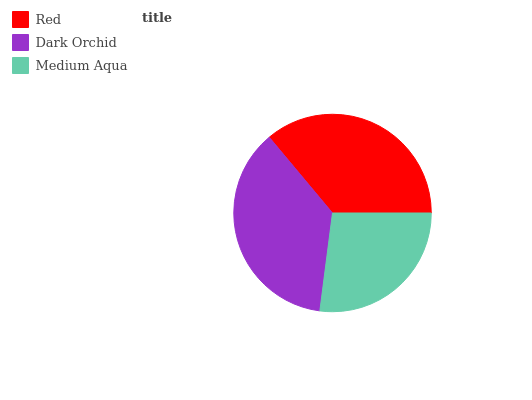Is Medium Aqua the minimum?
Answer yes or no. Yes. Is Dark Orchid the maximum?
Answer yes or no. Yes. Is Dark Orchid the minimum?
Answer yes or no. No. Is Medium Aqua the maximum?
Answer yes or no. No. Is Dark Orchid greater than Medium Aqua?
Answer yes or no. Yes. Is Medium Aqua less than Dark Orchid?
Answer yes or no. Yes. Is Medium Aqua greater than Dark Orchid?
Answer yes or no. No. Is Dark Orchid less than Medium Aqua?
Answer yes or no. No. Is Red the high median?
Answer yes or no. Yes. Is Red the low median?
Answer yes or no. Yes. Is Medium Aqua the high median?
Answer yes or no. No. Is Dark Orchid the low median?
Answer yes or no. No. 